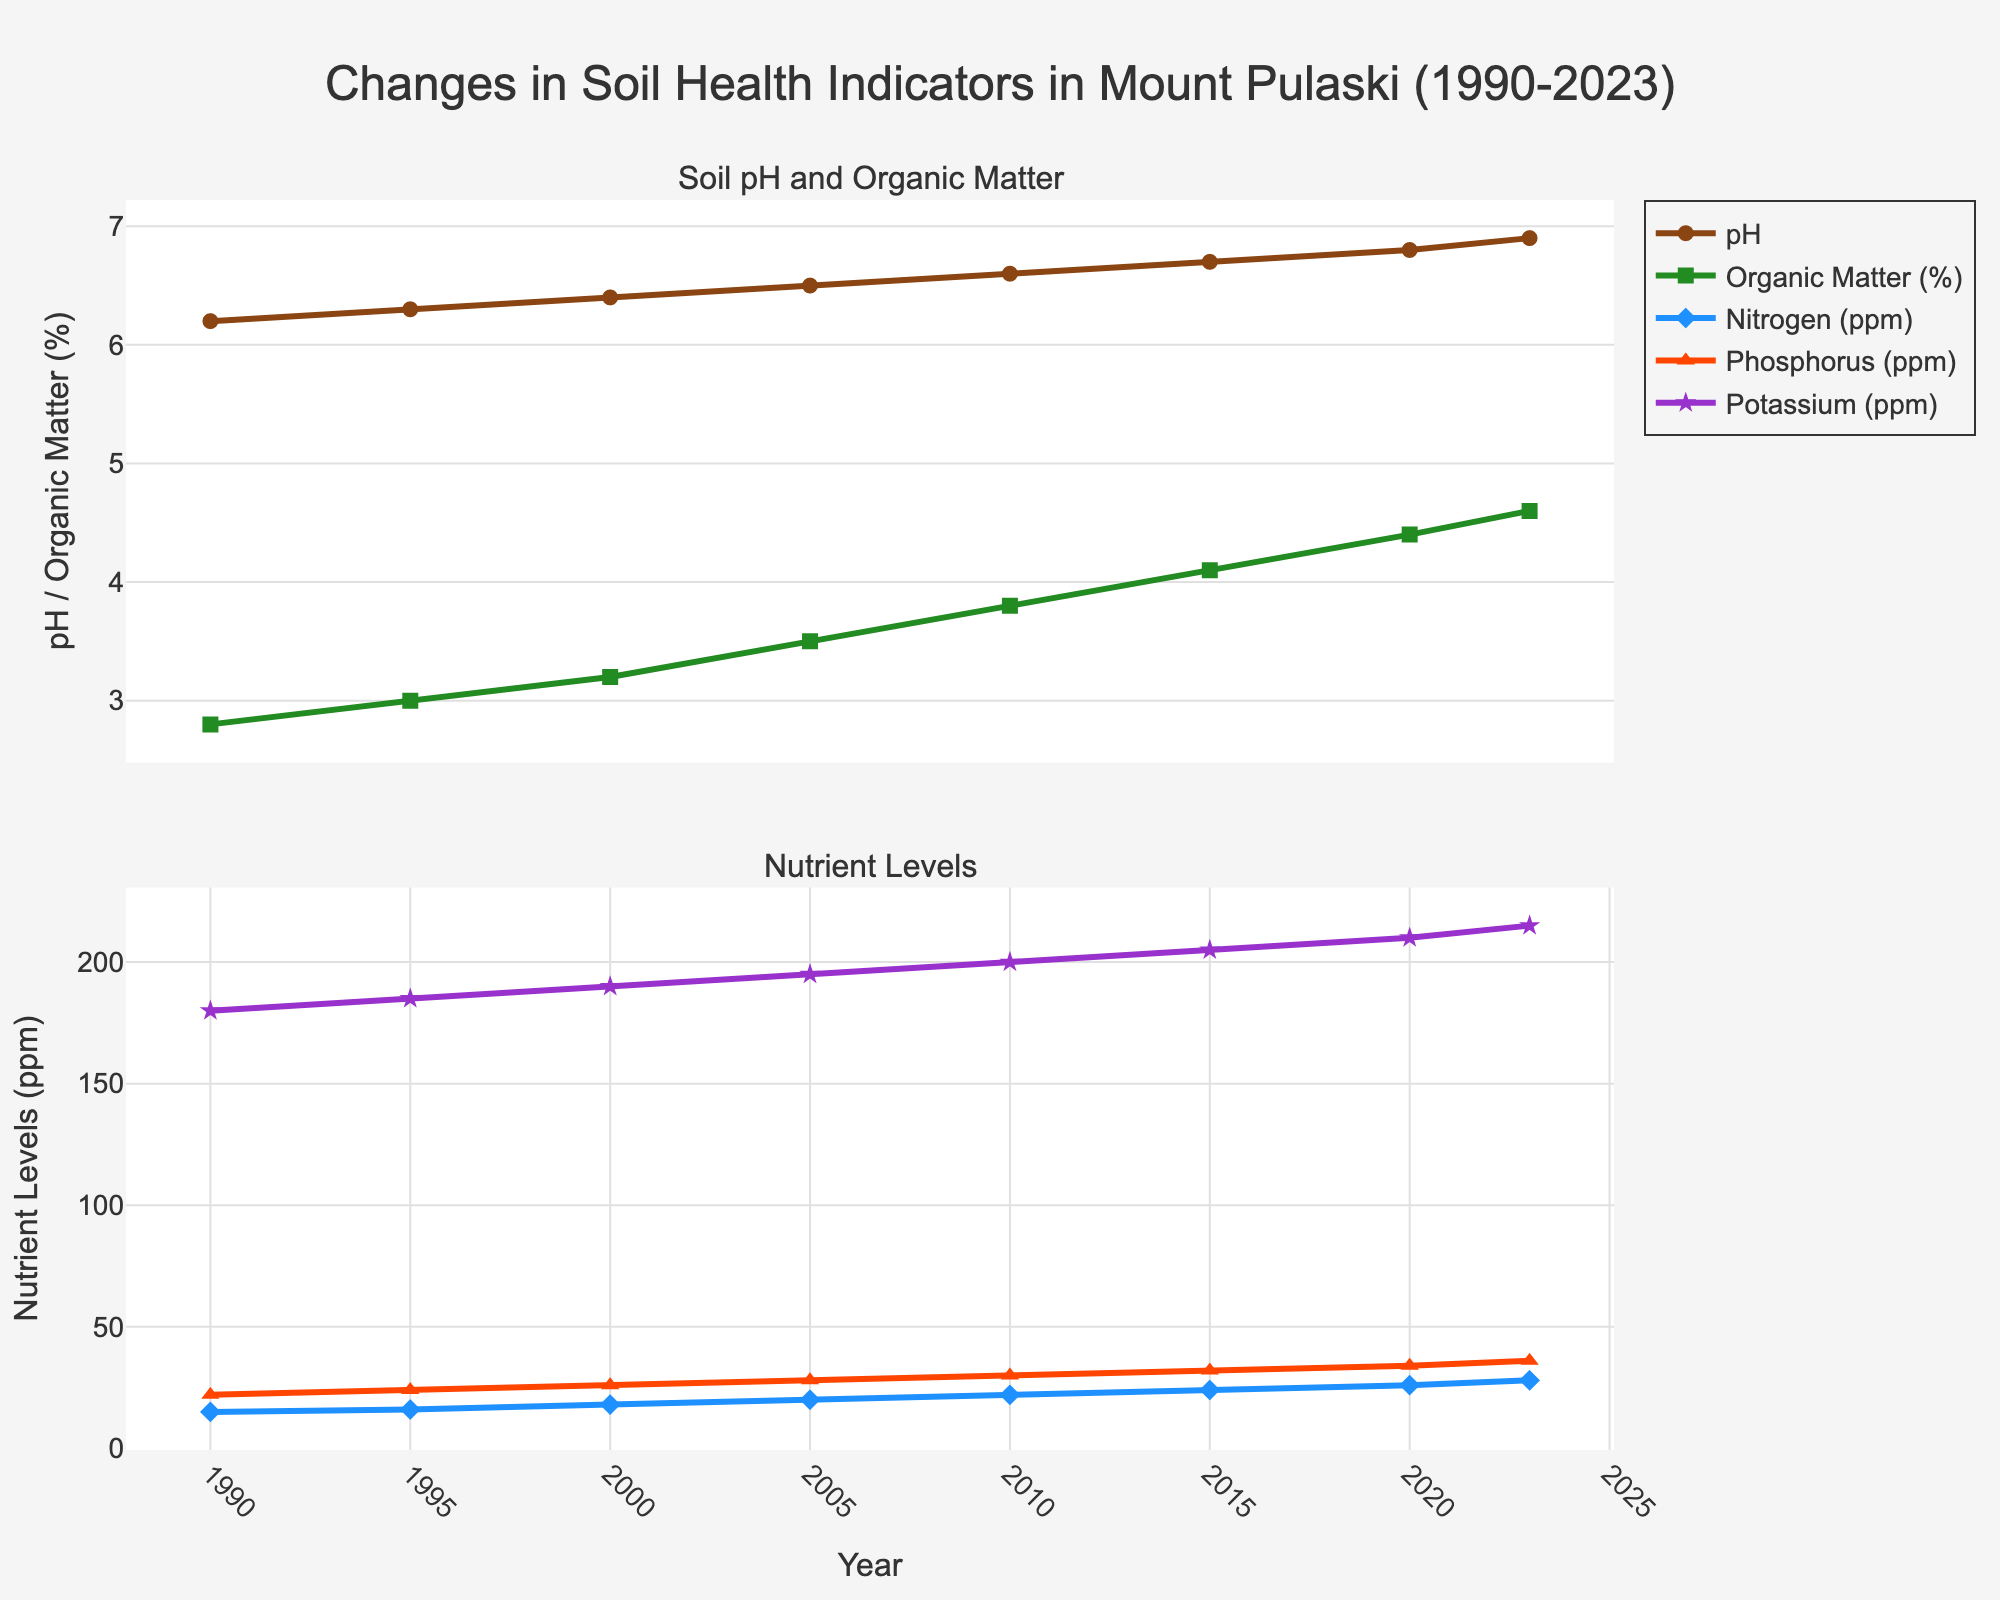What's the trend in soil pH from 1990 to 2023? To identify the trend, observe the pH values over the years in the first subplot. The pH value steadily increases from 6.2 in 1990 to 6.9 in 2023, indicating an overall upward trend.
Answer: Upward trend How much did the Organic Matter (%) increase from 1990 to 2023? To calculate the increase, subtract the Organic Matter (%) in 1990 from the value in 2023. The Organic Matter (%) in 1990 is 2.8% and in 2023 it is 4.6%. The increase is 4.6% - 2.8% = 1.8%.
Answer: 1.8% Which nutrient had the greatest increase in its level from 1990 to 2023? To find the greatest increase, compare the differences for Nitrogen (ppm), Phosphorus (ppm), and Potassium (ppm) between 1990 and 2023. Nitrogen increased by 13ppm, Phosphorus by 14ppm, and Potassium by 35ppm. Therefore, Potassium had the greatest increase.
Answer: Potassium What is the average pH value over the years? Calculate the average of the pH values. The pH values are 6.2, 6.3, 6.4, 6.5, 6.6, 6.7, 6.8, and 6.9. Sum these values: 6.2 + 6.3 + 6.4 + 6.5 + 6.6 + 6.7 + 6.8 + 6.9 = 52.4. Divide by the number of data points (8): 52.4 / 8 = 6.55.
Answer: 6.55 In which year did Nitrogen (ppm) see a significant increase compared to the previous year? To determine the year with a significant increase, observe the Nitrogen (ppm) values year by year. From 2000 to 2005, it increased from 18ppm to 20ppm, a significant jump compared to the previous increases of just 1-2ppm per period.
Answer: 2005 How did Phosphorus (ppm) levels change from 1995 to 2010? To observe the change, look at the Phosphorus (ppm) levels in 1995 and 2010. In 1995, it was 24ppm, and in 2010, it was 30ppm, showing an increase of 6ppm.
Answer: Increased by 6ppm What color represents the Organic Matter (%) in the chart? To determine the color, look at the color assigned to the Organic Matter (%) line in the first subplot. It is represented by a green line.
Answer: Green Between which years did the Potassium (ppm) level first reach 200? To identify this, check the Potassium (ppm) values. The level first reaches 200ppm in 2010 and continues to increase afterward.
Answer: 2010 What can be said about the trend of nutrient levels (Nitrogen, Phosphorus, Potassium) from 1990 to 2023? To determine the trend, observe the lines representing each nutrient in the second subplot. All three nutrients show an upward trend over the years, indicating consistent increases.
Answer: All upward trends How is the year 2015 significant in terms of soil health indicators? Examine the soil health indicators for the year 2015. Here, there is continued improvement where the pH, Organic Matter (%), Nitrogen (ppm), Phosphorus (ppm), and Potassium (ppm) all show noticeable increases compared to previous years.
Answer: Noticeable increases in all indicators 